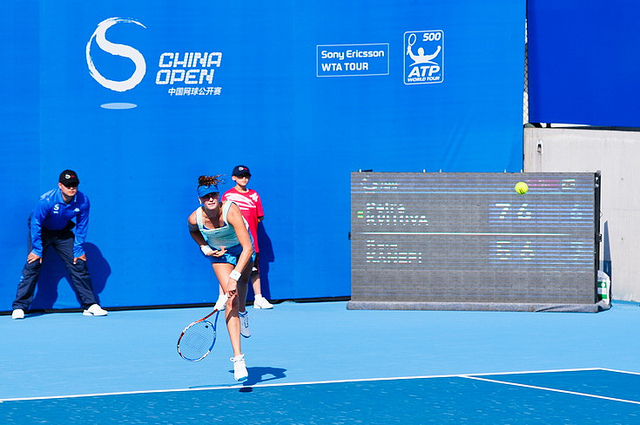Identify the text displayed in this image. CHINA OPEN Sony Ericsson S TOUR WTA 500 ATP KANEFI 56 6 76 